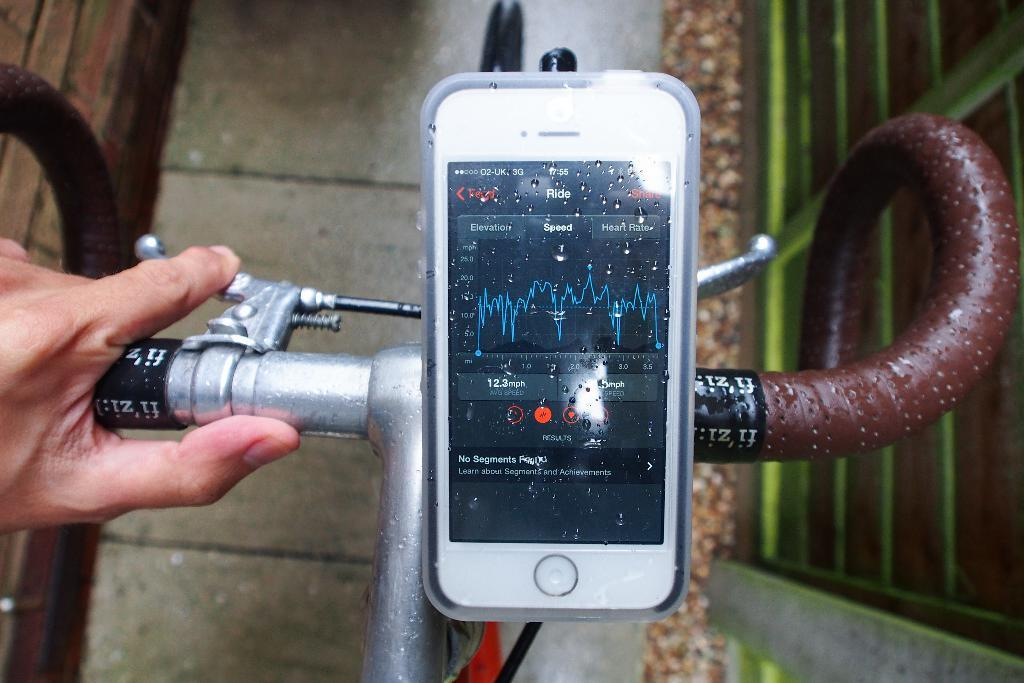<image>
Create a compact narrative representing the image presented. An app displayed on a phone displays details of a bike ride, such as speed and heart rate. 